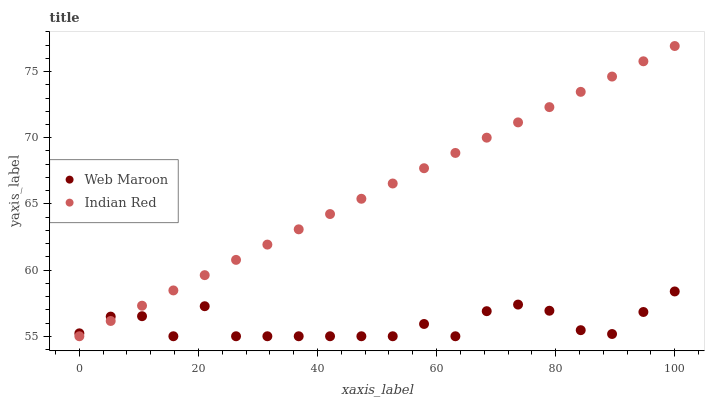Does Web Maroon have the minimum area under the curve?
Answer yes or no. Yes. Does Indian Red have the maximum area under the curve?
Answer yes or no. Yes. Does Indian Red have the minimum area under the curve?
Answer yes or no. No. Is Indian Red the smoothest?
Answer yes or no. Yes. Is Web Maroon the roughest?
Answer yes or no. Yes. Is Indian Red the roughest?
Answer yes or no. No. Does Web Maroon have the lowest value?
Answer yes or no. Yes. Does Indian Red have the highest value?
Answer yes or no. Yes. Does Indian Red intersect Web Maroon?
Answer yes or no. Yes. Is Indian Red less than Web Maroon?
Answer yes or no. No. Is Indian Red greater than Web Maroon?
Answer yes or no. No. 